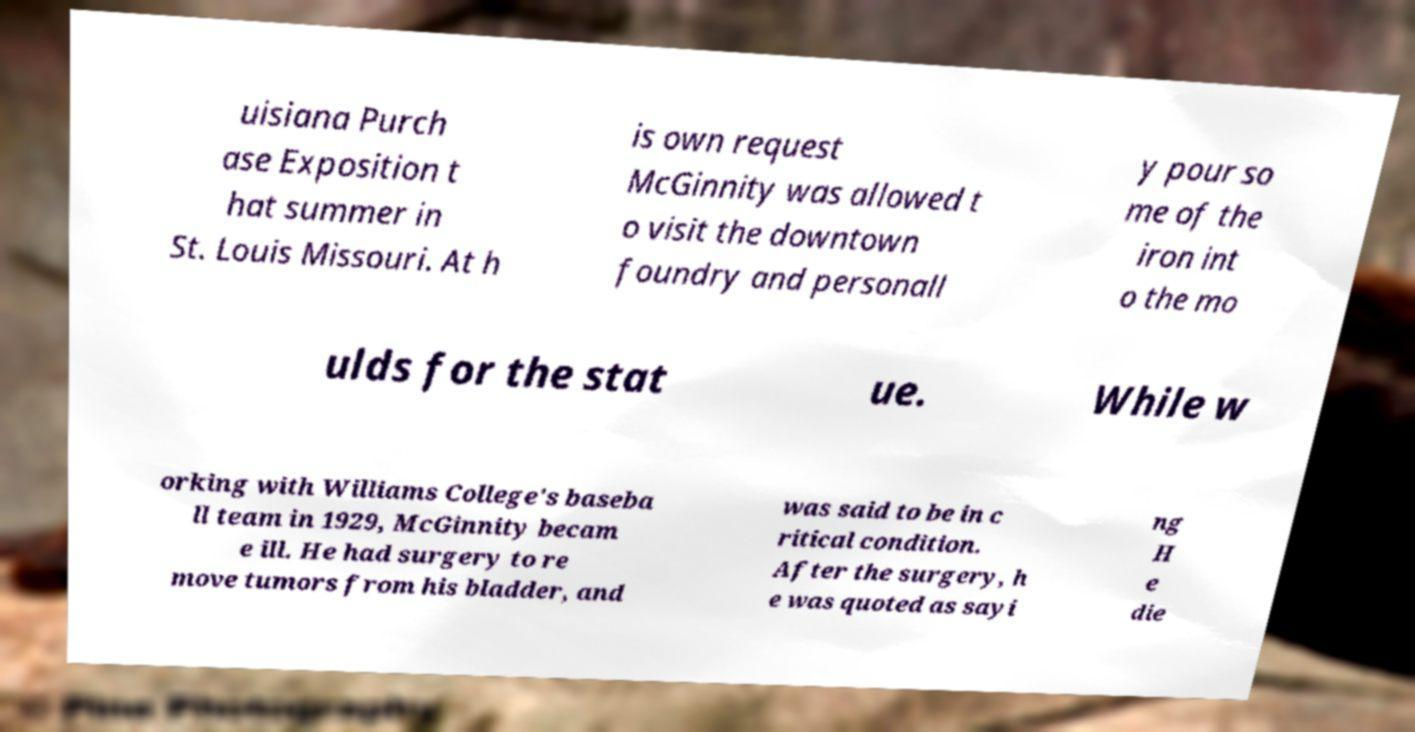What messages or text are displayed in this image? I need them in a readable, typed format. uisiana Purch ase Exposition t hat summer in St. Louis Missouri. At h is own request McGinnity was allowed t o visit the downtown foundry and personall y pour so me of the iron int o the mo ulds for the stat ue. While w orking with Williams College's baseba ll team in 1929, McGinnity becam e ill. He had surgery to re move tumors from his bladder, and was said to be in c ritical condition. After the surgery, h e was quoted as sayi ng H e die 